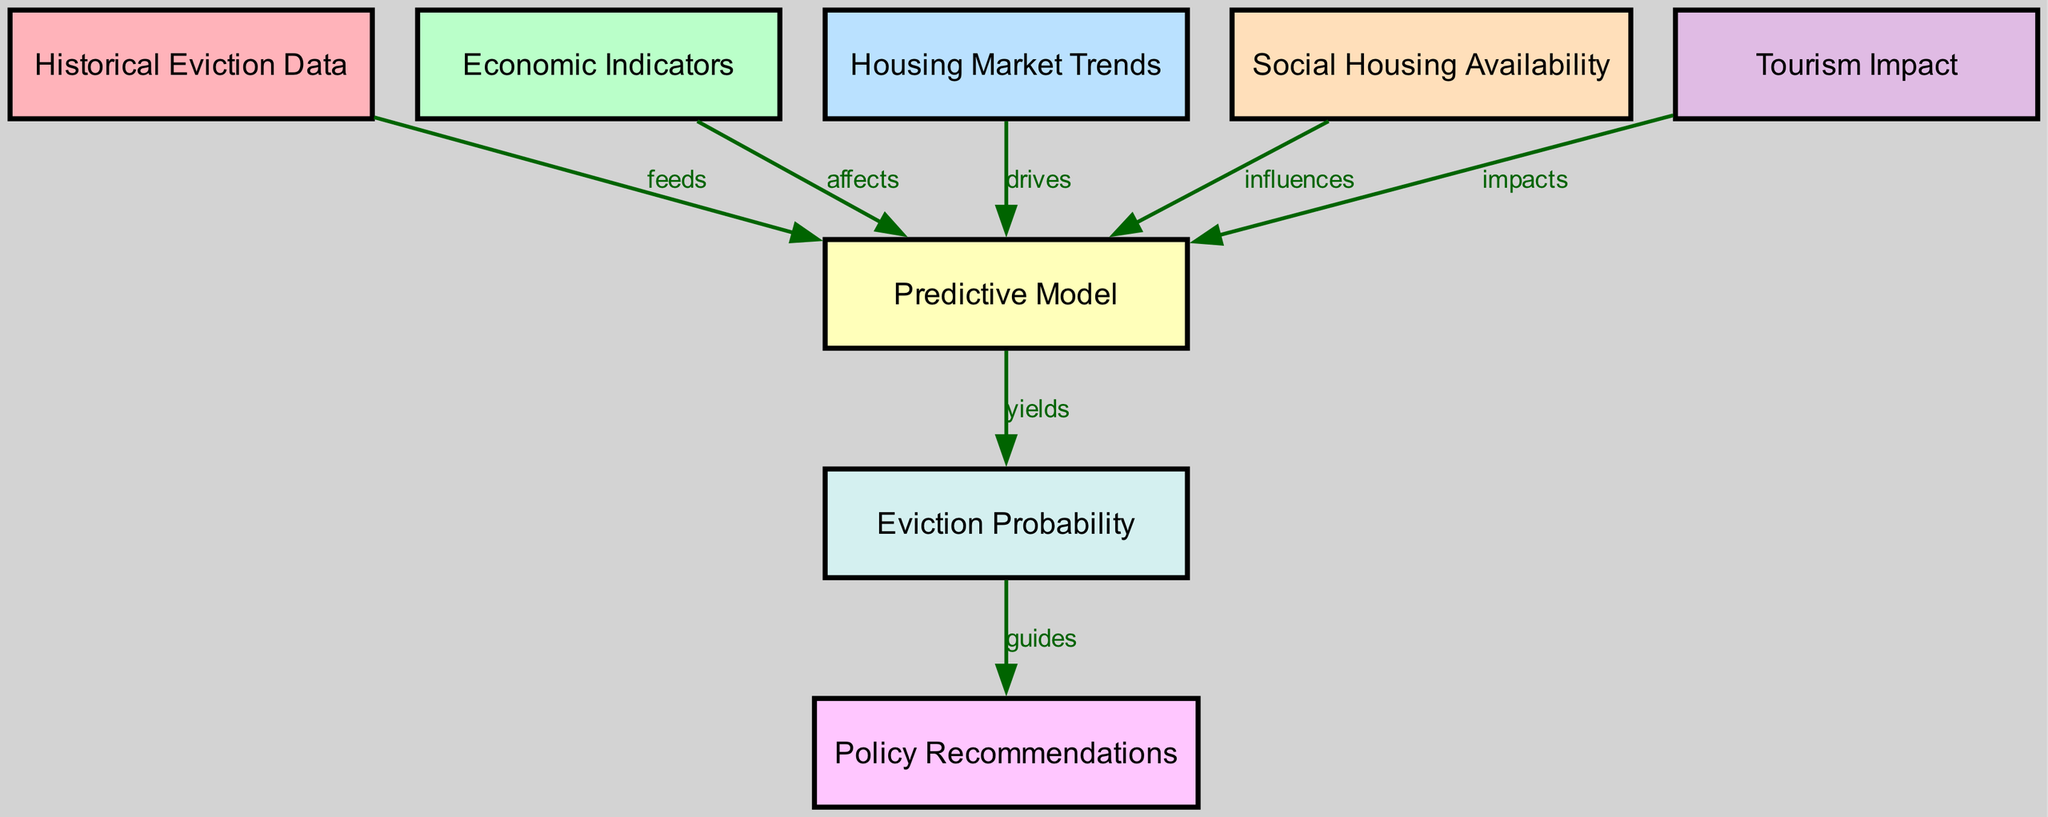What is the total number of nodes in the diagram? The diagram contains eight distinct nodes: Historical Eviction Data, Economic Indicators, Housing Market Trends, Predictive Model, Social Housing Availability, Tourism Impact, Eviction Probability, and Policy Recommendations.
Answer: Eight Which node influences the Predictive Model? The edges from Social Housing Availability point to the Predictive Model, indicating that Social Housing Availability influences it.
Answer: Social Housing Availability What type of relationship exists between Economic Indicators and the Predictive Model? The edge labeled "affects" from Economic Indicators to Predictive Model indicates that Economic Indicators have a direct impact on the Predictive Model.
Answer: Affects Which node yields Eviction Probability? The Predictive Model generates the Eviction Probability, as indicated by the edge labeled "yields" from Predictive Model to Eviction Probability.
Answer: Predictive Model What guides the formation of Policy Recommendations? The Eviction Probability, as indicated by the edge labeled "guides" between them, directs the creation of Policy Recommendations.
Answer: Eviction Probability Which two nodes have a direct impact on the Predictive Model? Both Economic Indicators and Tourism Impact (as indicated by their respective edges) have a direct effect on the Predictive Model, meaning they contribute to its function.
Answer: Economic Indicators and Tourism Impact How many edges are present in the diagram? There are seven edges connecting the nodes, indicating the relationships and flows between them.
Answer: Seven Which node directly feeds into the Predictive Model? The Historical Eviction Data provides input to the Predictive Model, as shown by the edge labeled "feeds."
Answer: Historical Eviction Data 